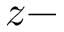<formula> <loc_0><loc_0><loc_500><loc_500>z -</formula> 